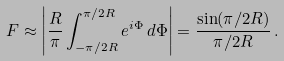Convert formula to latex. <formula><loc_0><loc_0><loc_500><loc_500>F \approx \left | \frac { R } { \pi } \int _ { - \pi / 2 R } ^ { \pi / 2 R } e ^ { i \Phi } \, d \Phi \right | = \frac { \sin ( \pi / 2 R ) } { \pi / 2 R } \, .</formula> 